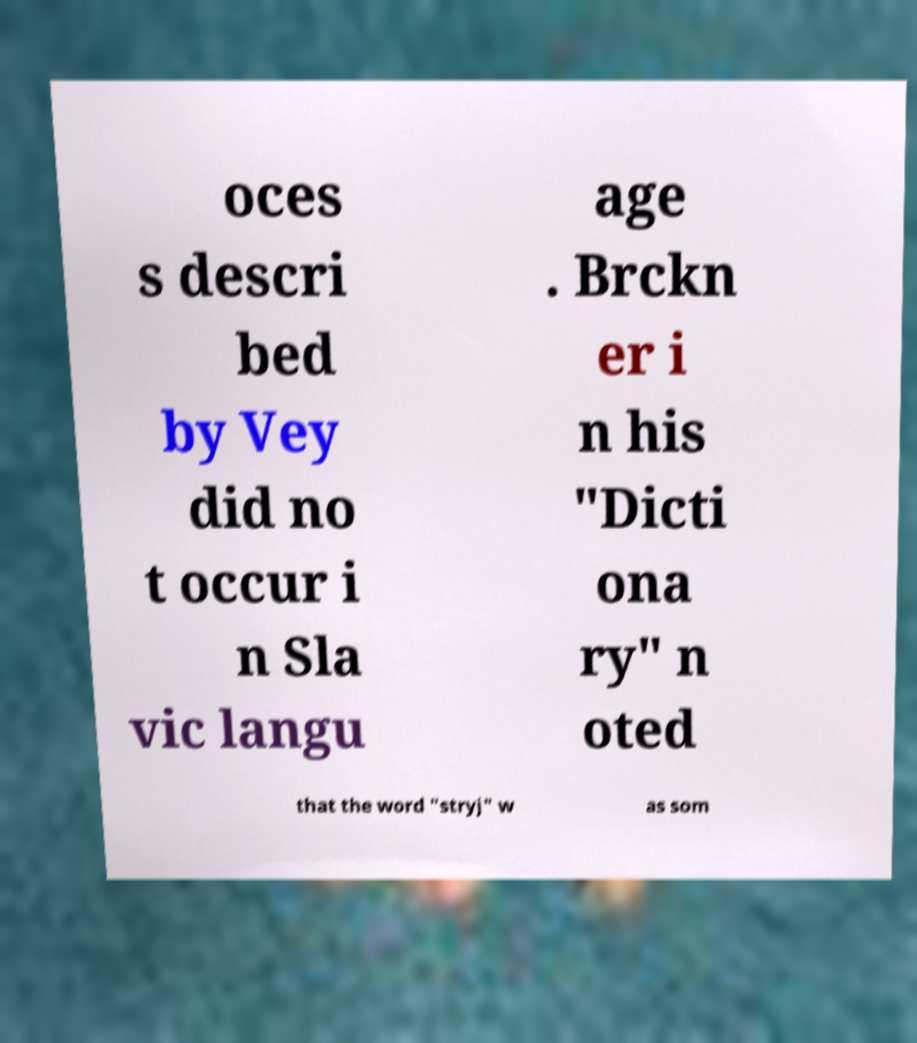Can you accurately transcribe the text from the provided image for me? oces s descri bed by Vey did no t occur i n Sla vic langu age . Brckn er i n his "Dicti ona ry" n oted that the word "stryj" w as som 